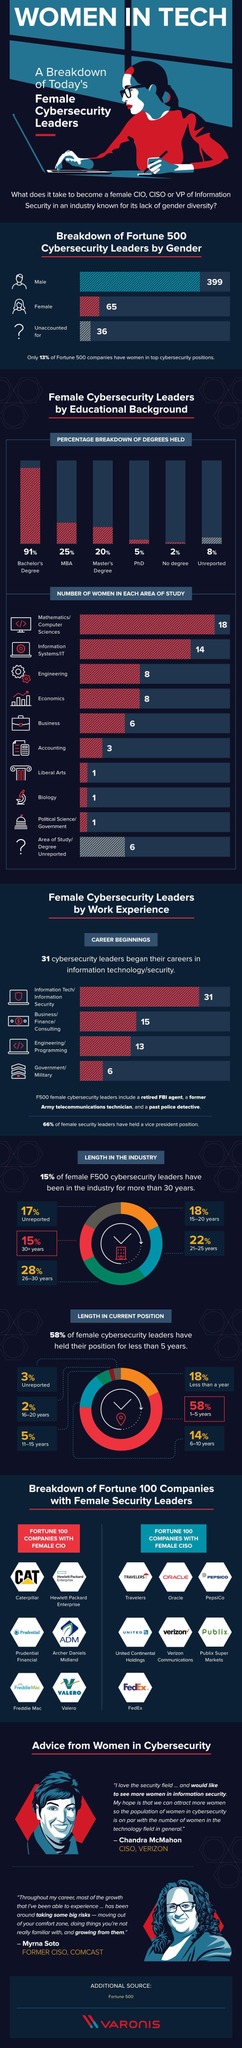What percentage of the female F500 cybersecurity leaders have been in the industry for 21-25 years?
Answer the question with a short phrase. 22% How many F500 female cybersecurity leaders began their careers in government or military? 6 Which degree is held by the majority of the female F500 cybersecurity leaders? Bachelor's Degree What is the number of female F500 cybersecurity leaders from Engineering background? 8 What percentage of female F500 cybersecurity leaders have held their position for less than a year? 18% What percentage of the female F500 cybersecurity leaders have been in the industry for 26-30 years? 28% What is the number of female F500 cybersecurity leaders? 65 What percentage of the female F500 cybersecurity leaders are PhD holders? 5% How many F500 female cybersecurity  leaders began their careers in Engineering or programming? 13 What percentage of the female F500 cybersecurity leaders held a MBA degree? 25% 